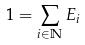<formula> <loc_0><loc_0><loc_500><loc_500>1 = \sum _ { i \in \mathbb { N } } E _ { i }</formula> 